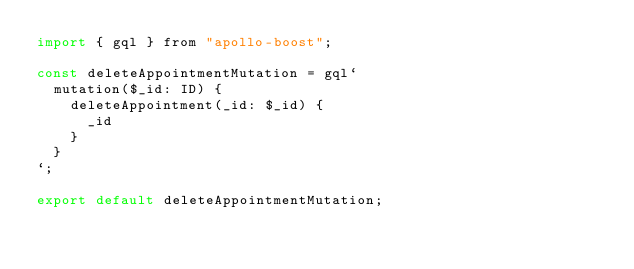Convert code to text. <code><loc_0><loc_0><loc_500><loc_500><_JavaScript_>import { gql } from "apollo-boost";

const deleteAppointmentMutation = gql`
  mutation($_id: ID) {
    deleteAppointment(_id: $_id) {
      _id
    }
  }
`;

export default deleteAppointmentMutation;
</code> 